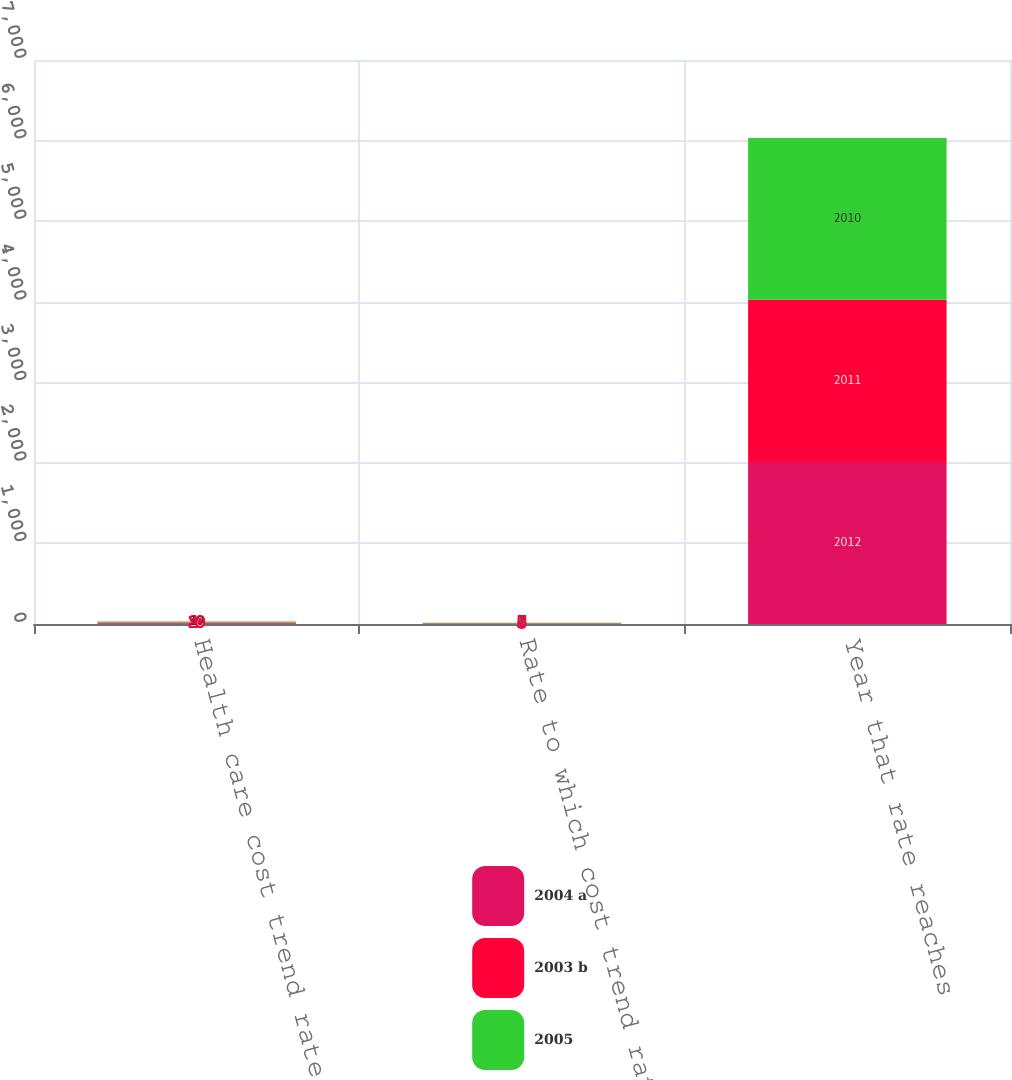Convert chart to OTSL. <chart><loc_0><loc_0><loc_500><loc_500><stacked_bar_chart><ecel><fcel>Health care cost trend rate<fcel>Rate to which cost trend rate<fcel>Year that rate reaches<nl><fcel>2004 a<fcel>10<fcel>5<fcel>2012<nl><fcel>2003 b<fcel>10<fcel>5<fcel>2011<nl><fcel>2005<fcel>10<fcel>5<fcel>2010<nl></chart> 